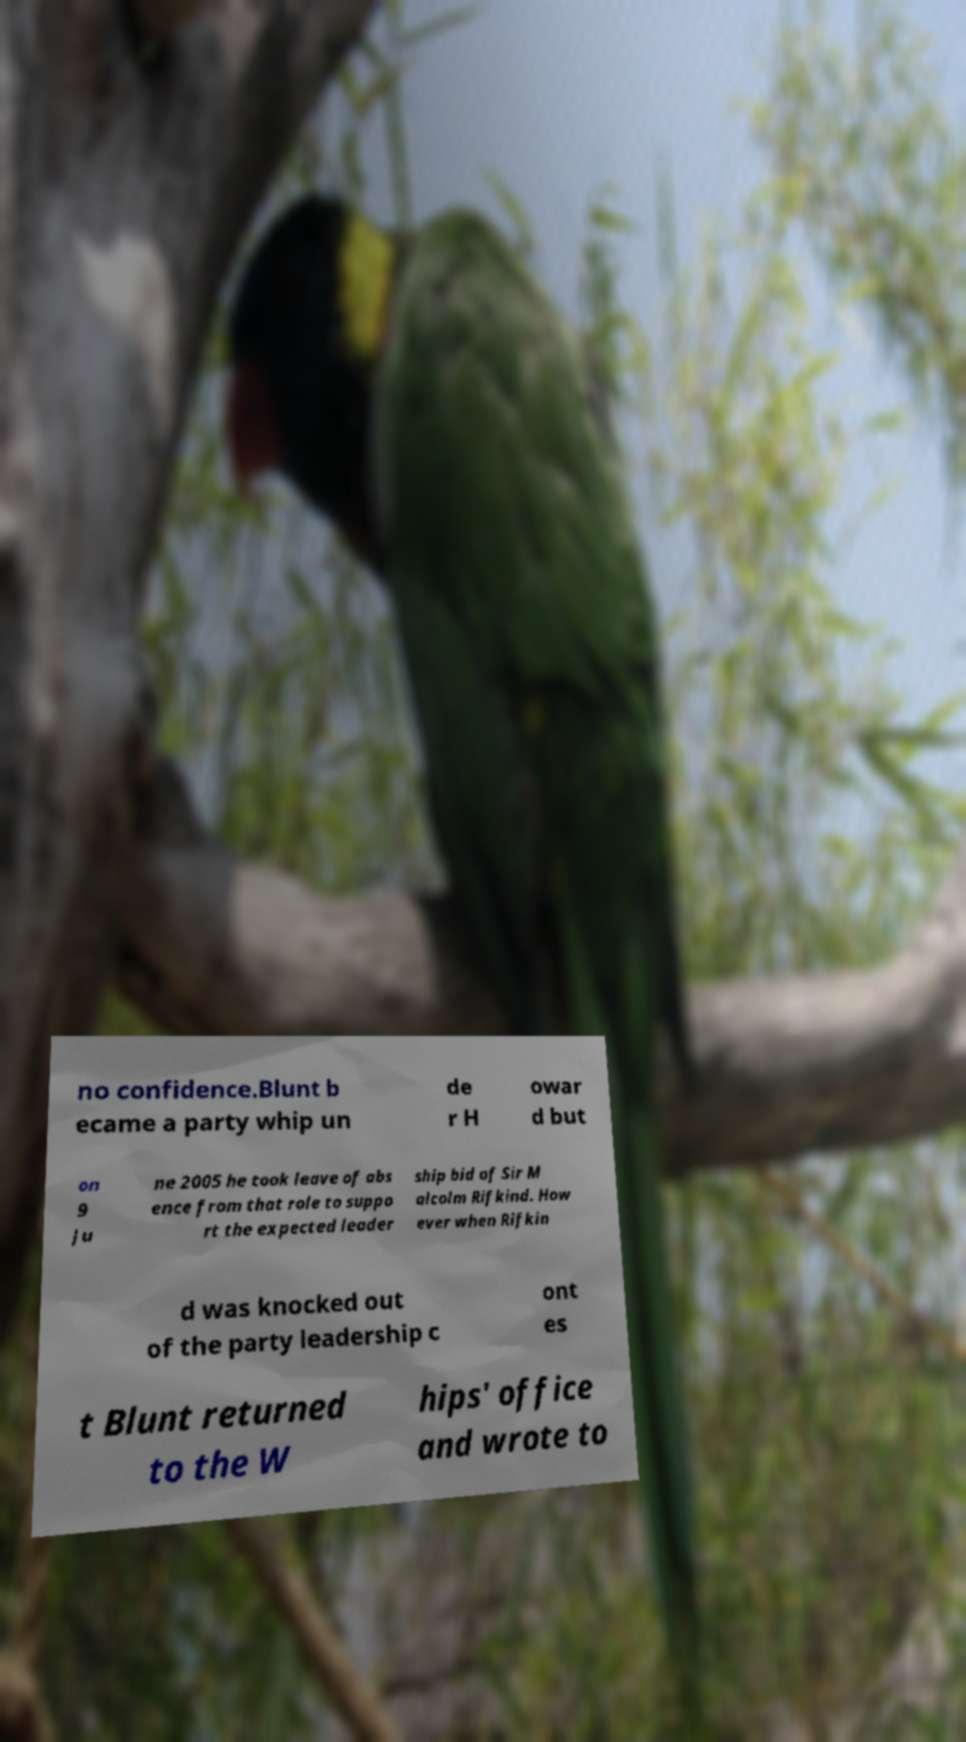Can you read and provide the text displayed in the image?This photo seems to have some interesting text. Can you extract and type it out for me? no confidence.Blunt b ecame a party whip un de r H owar d but on 9 Ju ne 2005 he took leave of abs ence from that role to suppo rt the expected leader ship bid of Sir M alcolm Rifkind. How ever when Rifkin d was knocked out of the party leadership c ont es t Blunt returned to the W hips' office and wrote to 